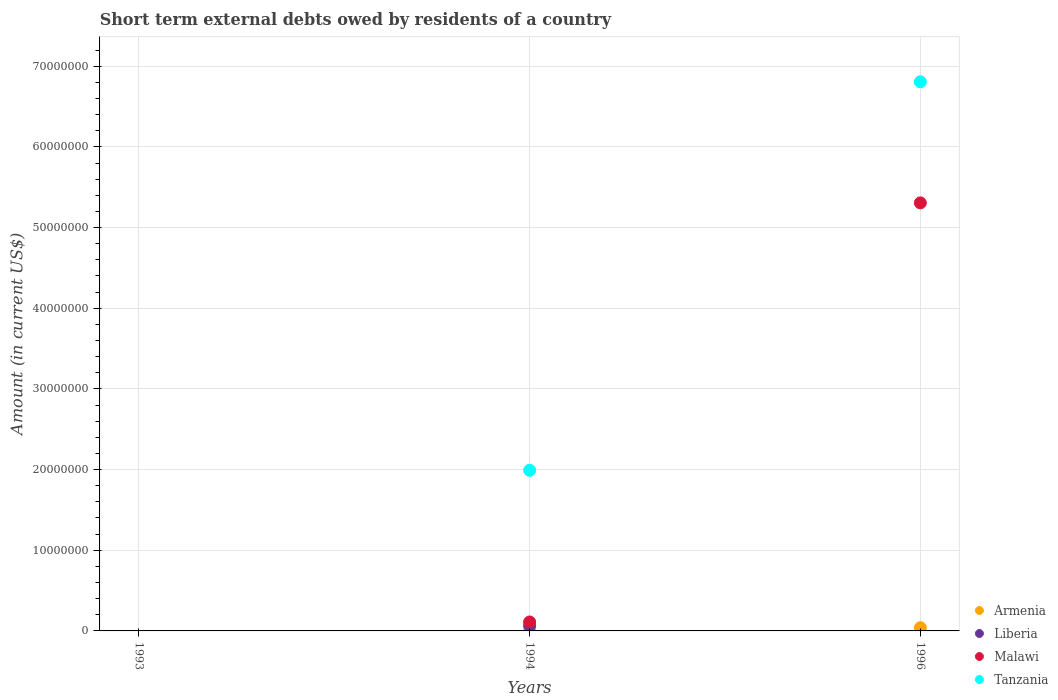In which year was the amount of short-term external debts owed by residents in Liberia maximum?
Give a very brief answer. 1994. What is the total amount of short-term external debts owed by residents in Liberia in the graph?
Offer a very short reply. 6.30e+05. What is the difference between the amount of short-term external debts owed by residents in Tanzania in 1994 and the amount of short-term external debts owed by residents in Armenia in 1996?
Give a very brief answer. 1.95e+07. What is the average amount of short-term external debts owed by residents in Malawi per year?
Your response must be concise. 1.81e+07. In the year 1996, what is the difference between the amount of short-term external debts owed by residents in Armenia and amount of short-term external debts owed by residents in Malawi?
Offer a very short reply. -5.27e+07. What is the ratio of the amount of short-term external debts owed by residents in Tanzania in 1994 to that in 1996?
Offer a very short reply. 0.29. Is the sum of the amount of short-term external debts owed by residents in Tanzania in 1994 and 1996 greater than the maximum amount of short-term external debts owed by residents in Liberia across all years?
Your answer should be compact. Yes. Is the amount of short-term external debts owed by residents in Malawi strictly greater than the amount of short-term external debts owed by residents in Tanzania over the years?
Provide a succinct answer. No. How many years are there in the graph?
Give a very brief answer. 3. Does the graph contain any zero values?
Your answer should be very brief. Yes. What is the title of the graph?
Your response must be concise. Short term external debts owed by residents of a country. Does "Switzerland" appear as one of the legend labels in the graph?
Offer a very short reply. No. What is the label or title of the Y-axis?
Your answer should be compact. Amount (in current US$). What is the Amount (in current US$) in Liberia in 1993?
Your response must be concise. 0. What is the Amount (in current US$) in Malawi in 1993?
Offer a terse response. 0. What is the Amount (in current US$) of Armenia in 1994?
Keep it short and to the point. 0. What is the Amount (in current US$) in Liberia in 1994?
Give a very brief answer. 6.30e+05. What is the Amount (in current US$) in Malawi in 1994?
Your response must be concise. 1.11e+06. What is the Amount (in current US$) in Tanzania in 1994?
Your answer should be very brief. 1.99e+07. What is the Amount (in current US$) in Malawi in 1996?
Ensure brevity in your answer.  5.31e+07. What is the Amount (in current US$) of Tanzania in 1996?
Offer a terse response. 6.81e+07. Across all years, what is the maximum Amount (in current US$) in Liberia?
Make the answer very short. 6.30e+05. Across all years, what is the maximum Amount (in current US$) in Malawi?
Keep it short and to the point. 5.31e+07. Across all years, what is the maximum Amount (in current US$) in Tanzania?
Your answer should be compact. 6.81e+07. Across all years, what is the minimum Amount (in current US$) of Malawi?
Ensure brevity in your answer.  0. What is the total Amount (in current US$) in Armenia in the graph?
Your answer should be compact. 4.00e+05. What is the total Amount (in current US$) in Liberia in the graph?
Your response must be concise. 6.30e+05. What is the total Amount (in current US$) in Malawi in the graph?
Offer a very short reply. 5.42e+07. What is the total Amount (in current US$) of Tanzania in the graph?
Your answer should be very brief. 8.80e+07. What is the difference between the Amount (in current US$) in Malawi in 1994 and that in 1996?
Ensure brevity in your answer.  -5.20e+07. What is the difference between the Amount (in current US$) in Tanzania in 1994 and that in 1996?
Keep it short and to the point. -4.82e+07. What is the difference between the Amount (in current US$) of Liberia in 1994 and the Amount (in current US$) of Malawi in 1996?
Give a very brief answer. -5.24e+07. What is the difference between the Amount (in current US$) of Liberia in 1994 and the Amount (in current US$) of Tanzania in 1996?
Provide a short and direct response. -6.74e+07. What is the difference between the Amount (in current US$) in Malawi in 1994 and the Amount (in current US$) in Tanzania in 1996?
Give a very brief answer. -6.70e+07. What is the average Amount (in current US$) of Armenia per year?
Your answer should be very brief. 1.33e+05. What is the average Amount (in current US$) of Liberia per year?
Offer a terse response. 2.10e+05. What is the average Amount (in current US$) in Malawi per year?
Provide a succinct answer. 1.81e+07. What is the average Amount (in current US$) of Tanzania per year?
Your response must be concise. 2.93e+07. In the year 1994, what is the difference between the Amount (in current US$) in Liberia and Amount (in current US$) in Malawi?
Keep it short and to the point. -4.80e+05. In the year 1994, what is the difference between the Amount (in current US$) of Liberia and Amount (in current US$) of Tanzania?
Ensure brevity in your answer.  -1.93e+07. In the year 1994, what is the difference between the Amount (in current US$) in Malawi and Amount (in current US$) in Tanzania?
Your response must be concise. -1.88e+07. In the year 1996, what is the difference between the Amount (in current US$) of Armenia and Amount (in current US$) of Malawi?
Give a very brief answer. -5.27e+07. In the year 1996, what is the difference between the Amount (in current US$) of Armenia and Amount (in current US$) of Tanzania?
Your response must be concise. -6.77e+07. In the year 1996, what is the difference between the Amount (in current US$) in Malawi and Amount (in current US$) in Tanzania?
Ensure brevity in your answer.  -1.50e+07. What is the ratio of the Amount (in current US$) in Malawi in 1994 to that in 1996?
Offer a very short reply. 0.02. What is the ratio of the Amount (in current US$) in Tanzania in 1994 to that in 1996?
Offer a terse response. 0.29. What is the difference between the highest and the lowest Amount (in current US$) in Armenia?
Your response must be concise. 4.00e+05. What is the difference between the highest and the lowest Amount (in current US$) in Liberia?
Give a very brief answer. 6.30e+05. What is the difference between the highest and the lowest Amount (in current US$) in Malawi?
Provide a succinct answer. 5.31e+07. What is the difference between the highest and the lowest Amount (in current US$) in Tanzania?
Ensure brevity in your answer.  6.81e+07. 